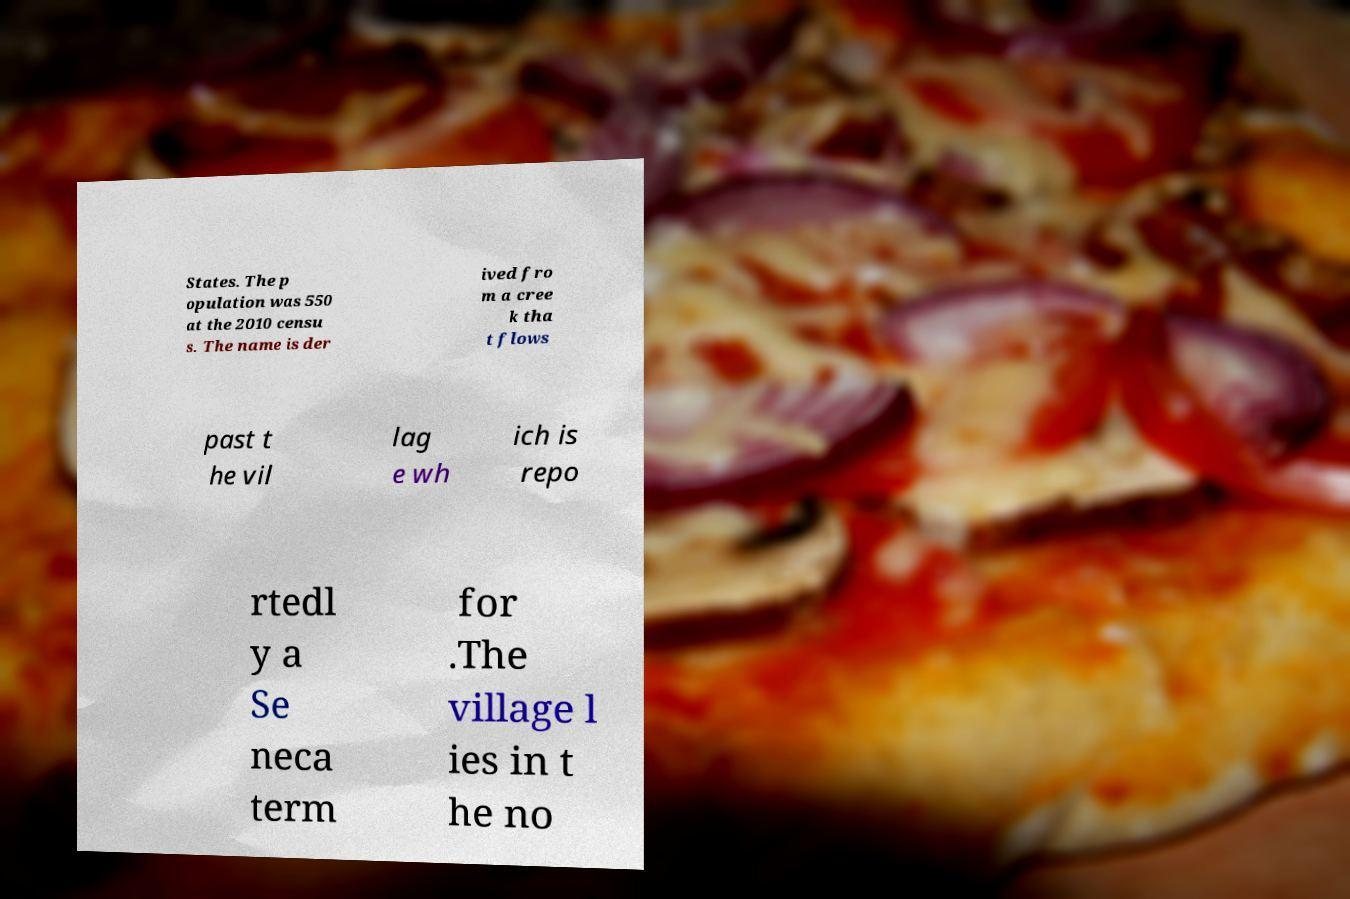For documentation purposes, I need the text within this image transcribed. Could you provide that? States. The p opulation was 550 at the 2010 censu s. The name is der ived fro m a cree k tha t flows past t he vil lag e wh ich is repo rtedl y a Se neca term for .The village l ies in t he no 